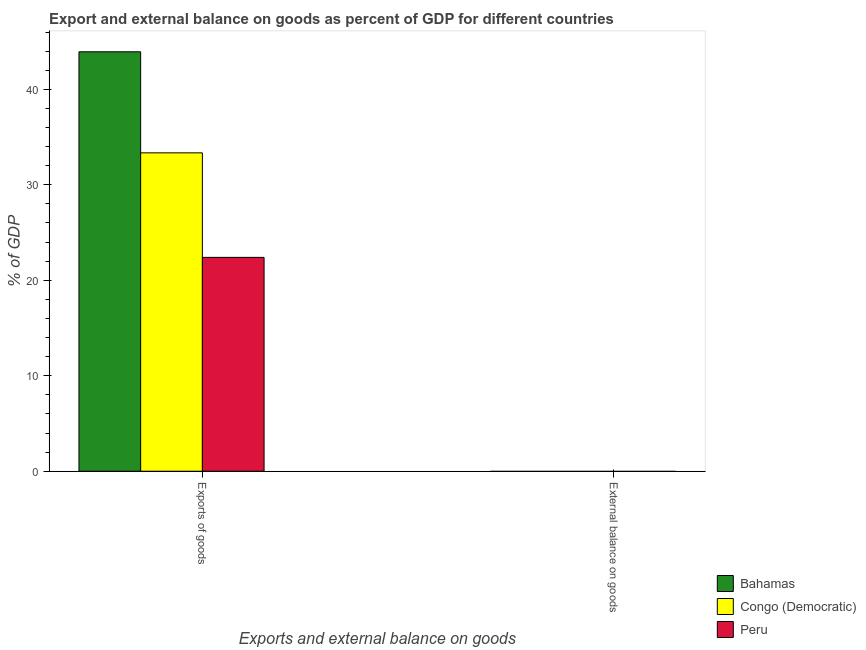How many different coloured bars are there?
Offer a very short reply. 3. Are the number of bars per tick equal to the number of legend labels?
Offer a terse response. No. Are the number of bars on each tick of the X-axis equal?
Offer a very short reply. No. How many bars are there on the 2nd tick from the right?
Offer a terse response. 3. What is the label of the 2nd group of bars from the left?
Give a very brief answer. External balance on goods. What is the export of goods as percentage of gdp in Peru?
Your answer should be compact. 22.4. Across all countries, what is the maximum export of goods as percentage of gdp?
Ensure brevity in your answer.  43.93. Across all countries, what is the minimum external balance on goods as percentage of gdp?
Offer a terse response. 0. In which country was the export of goods as percentage of gdp maximum?
Offer a terse response. Bahamas. What is the total export of goods as percentage of gdp in the graph?
Offer a terse response. 99.68. What is the difference between the export of goods as percentage of gdp in Bahamas and that in Congo (Democratic)?
Your answer should be very brief. 10.58. What is the difference between the export of goods as percentage of gdp in Peru and the external balance on goods as percentage of gdp in Bahamas?
Offer a terse response. 22.4. What is the average export of goods as percentage of gdp per country?
Ensure brevity in your answer.  33.23. In how many countries, is the export of goods as percentage of gdp greater than 30 %?
Offer a very short reply. 2. What is the ratio of the export of goods as percentage of gdp in Bahamas to that in Peru?
Your response must be concise. 1.96. Is the export of goods as percentage of gdp in Congo (Democratic) less than that in Peru?
Keep it short and to the point. No. How many bars are there?
Your response must be concise. 3. What is the difference between two consecutive major ticks on the Y-axis?
Your answer should be compact. 10. How are the legend labels stacked?
Your answer should be very brief. Vertical. What is the title of the graph?
Provide a succinct answer. Export and external balance on goods as percent of GDP for different countries. What is the label or title of the X-axis?
Give a very brief answer. Exports and external balance on goods. What is the label or title of the Y-axis?
Your response must be concise. % of GDP. What is the % of GDP of Bahamas in Exports of goods?
Offer a terse response. 43.93. What is the % of GDP of Congo (Democratic) in Exports of goods?
Provide a succinct answer. 33.35. What is the % of GDP in Peru in Exports of goods?
Give a very brief answer. 22.4. Across all Exports and external balance on goods, what is the maximum % of GDP in Bahamas?
Provide a succinct answer. 43.93. Across all Exports and external balance on goods, what is the maximum % of GDP of Congo (Democratic)?
Offer a very short reply. 33.35. Across all Exports and external balance on goods, what is the maximum % of GDP in Peru?
Make the answer very short. 22.4. Across all Exports and external balance on goods, what is the minimum % of GDP in Congo (Democratic)?
Ensure brevity in your answer.  0. Across all Exports and external balance on goods, what is the minimum % of GDP in Peru?
Make the answer very short. 0. What is the total % of GDP in Bahamas in the graph?
Your answer should be very brief. 43.93. What is the total % of GDP in Congo (Democratic) in the graph?
Provide a succinct answer. 33.35. What is the total % of GDP in Peru in the graph?
Provide a succinct answer. 22.4. What is the average % of GDP in Bahamas per Exports and external balance on goods?
Offer a terse response. 21.97. What is the average % of GDP of Congo (Democratic) per Exports and external balance on goods?
Your answer should be very brief. 16.67. What is the average % of GDP of Peru per Exports and external balance on goods?
Your answer should be very brief. 11.2. What is the difference between the % of GDP in Bahamas and % of GDP in Congo (Democratic) in Exports of goods?
Keep it short and to the point. 10.59. What is the difference between the % of GDP of Bahamas and % of GDP of Peru in Exports of goods?
Provide a short and direct response. 21.53. What is the difference between the % of GDP in Congo (Democratic) and % of GDP in Peru in Exports of goods?
Your answer should be compact. 10.95. What is the difference between the highest and the lowest % of GDP of Bahamas?
Provide a succinct answer. 43.93. What is the difference between the highest and the lowest % of GDP in Congo (Democratic)?
Provide a short and direct response. 33.35. What is the difference between the highest and the lowest % of GDP in Peru?
Provide a succinct answer. 22.4. 